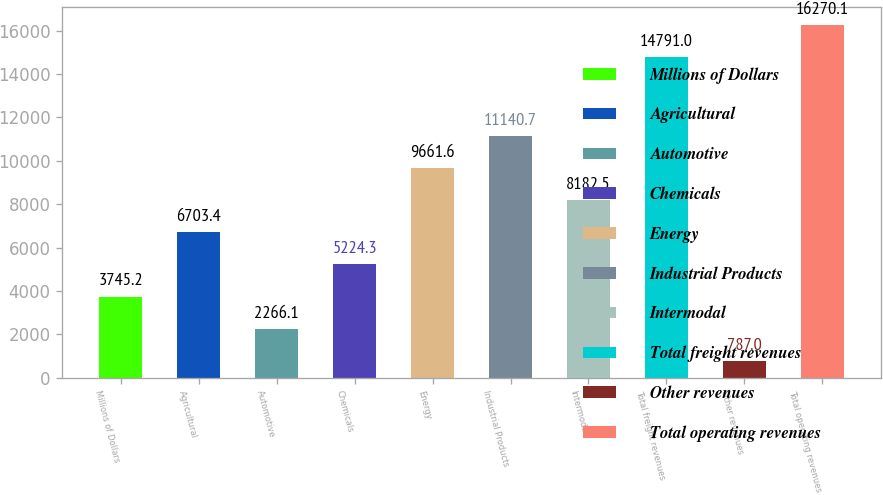Convert chart. <chart><loc_0><loc_0><loc_500><loc_500><bar_chart><fcel>Millions of Dollars<fcel>Agricultural<fcel>Automotive<fcel>Chemicals<fcel>Energy<fcel>Industrial Products<fcel>Intermodal<fcel>Total freight revenues<fcel>Other revenues<fcel>Total operating revenues<nl><fcel>3745.2<fcel>6703.4<fcel>2266.1<fcel>5224.3<fcel>9661.6<fcel>11140.7<fcel>8182.5<fcel>14791<fcel>787<fcel>16270.1<nl></chart> 